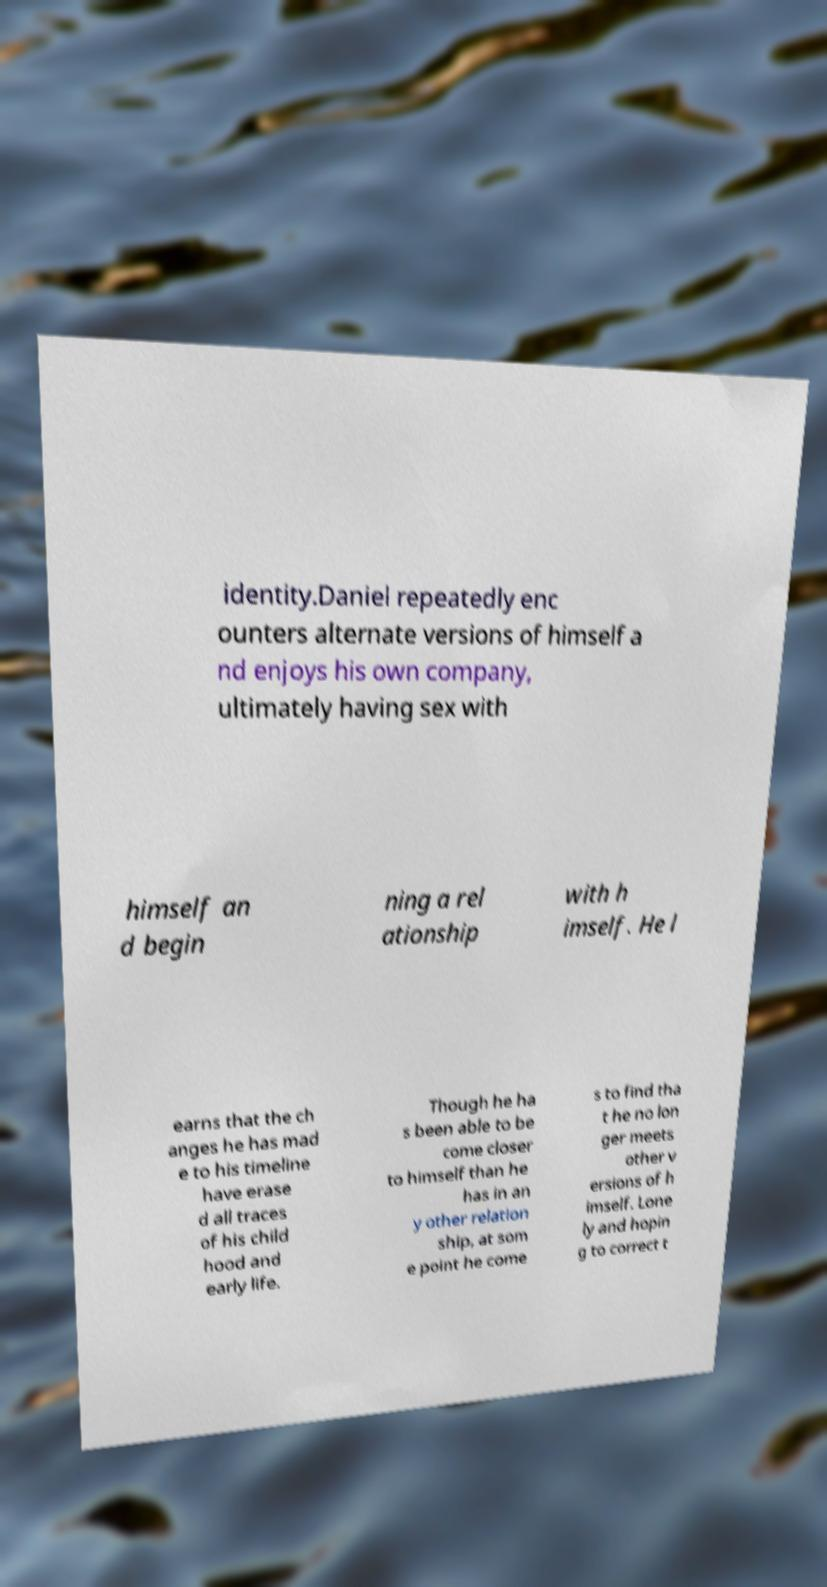For documentation purposes, I need the text within this image transcribed. Could you provide that? identity.Daniel repeatedly enc ounters alternate versions of himself a nd enjoys his own company, ultimately having sex with himself an d begin ning a rel ationship with h imself. He l earns that the ch anges he has mad e to his timeline have erase d all traces of his child hood and early life. Though he ha s been able to be come closer to himself than he has in an y other relation ship, at som e point he come s to find tha t he no lon ger meets other v ersions of h imself. Lone ly and hopin g to correct t 